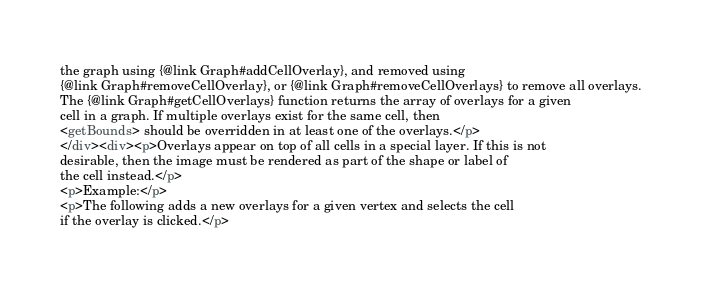Convert code to text. <code><loc_0><loc_0><loc_500><loc_500><_HTML_>the graph using {@link Graph#addCellOverlay}, and removed using
{@link Graph#removeCellOverlay}, or {@link Graph#removeCellOverlays} to remove all overlays.
The {@link Graph#getCellOverlays} function returns the array of overlays for a given
cell in a graph. If multiple overlays exist for the same cell, then
<getBounds> should be overridden in at least one of the overlays.</p>
</div><div><p>Overlays appear on top of all cells in a special layer. If this is not
desirable, then the image must be rendered as part of the shape or label of
the cell instead.</p>
<p>Example:</p>
<p>The following adds a new overlays for a given vertex and selects the cell
if the overlay is clicked.</p></code> 